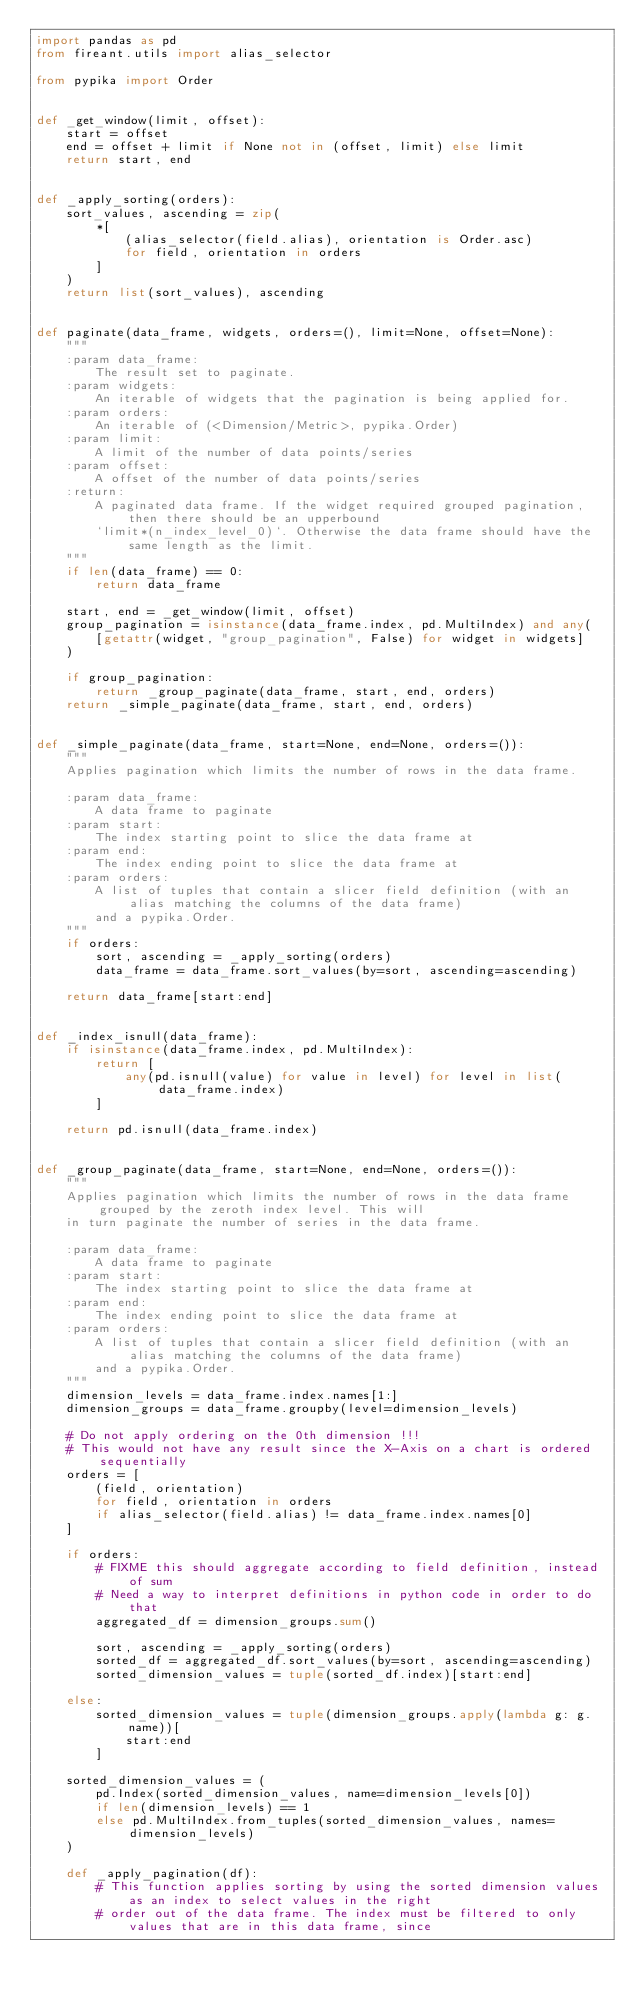Convert code to text. <code><loc_0><loc_0><loc_500><loc_500><_Python_>import pandas as pd
from fireant.utils import alias_selector

from pypika import Order


def _get_window(limit, offset):
    start = offset
    end = offset + limit if None not in (offset, limit) else limit
    return start, end


def _apply_sorting(orders):
    sort_values, ascending = zip(
        *[
            (alias_selector(field.alias), orientation is Order.asc)
            for field, orientation in orders
        ]
    )
    return list(sort_values), ascending


def paginate(data_frame, widgets, orders=(), limit=None, offset=None):
    """
    :param data_frame:
        The result set to paginate.
    :param widgets:
        An iterable of widgets that the pagination is being applied for.
    :param orders:
        An iterable of (<Dimension/Metric>, pypika.Order)
    :param limit:
        A limit of the number of data points/series
    :param offset:
        A offset of the number of data points/series
    :return:
        A paginated data frame. If the widget required grouped pagination, then there should be an upperbound
        `limit*(n_index_level_0)`. Otherwise the data frame should have the same length as the limit.
    """
    if len(data_frame) == 0:
        return data_frame

    start, end = _get_window(limit, offset)
    group_pagination = isinstance(data_frame.index, pd.MultiIndex) and any(
        [getattr(widget, "group_pagination", False) for widget in widgets]
    )

    if group_pagination:
        return _group_paginate(data_frame, start, end, orders)
    return _simple_paginate(data_frame, start, end, orders)


def _simple_paginate(data_frame, start=None, end=None, orders=()):
    """
    Applies pagination which limits the number of rows in the data frame.

    :param data_frame:
        A data frame to paginate
    :param start:
        The index starting point to slice the data frame at
    :param end:
        The index ending point to slice the data frame at
    :param orders:
        A list of tuples that contain a slicer field definition (with an alias matching the columns of the data frame)
        and a pypika.Order.
    """
    if orders:
        sort, ascending = _apply_sorting(orders)
        data_frame = data_frame.sort_values(by=sort, ascending=ascending)

    return data_frame[start:end]


def _index_isnull(data_frame):
    if isinstance(data_frame.index, pd.MultiIndex):
        return [
            any(pd.isnull(value) for value in level) for level in list(data_frame.index)
        ]

    return pd.isnull(data_frame.index)


def _group_paginate(data_frame, start=None, end=None, orders=()):
    """
    Applies pagination which limits the number of rows in the data frame grouped by the zeroth index level. This will
    in turn paginate the number of series in the data frame.

    :param data_frame:
        A data frame to paginate
    :param start:
        The index starting point to slice the data frame at
    :param end:
        The index ending point to slice the data frame at
    :param orders:
        A list of tuples that contain a slicer field definition (with an alias matching the columns of the data frame)
        and a pypika.Order.
    """
    dimension_levels = data_frame.index.names[1:]
    dimension_groups = data_frame.groupby(level=dimension_levels)

    # Do not apply ordering on the 0th dimension !!!
    # This would not have any result since the X-Axis on a chart is ordered sequentially
    orders = [
        (field, orientation)
        for field, orientation in orders
        if alias_selector(field.alias) != data_frame.index.names[0]
    ]

    if orders:
        # FIXME this should aggregate according to field definition, instead of sum
        # Need a way to interpret definitions in python code in order to do that
        aggregated_df = dimension_groups.sum()

        sort, ascending = _apply_sorting(orders)
        sorted_df = aggregated_df.sort_values(by=sort, ascending=ascending)
        sorted_dimension_values = tuple(sorted_df.index)[start:end]

    else:
        sorted_dimension_values = tuple(dimension_groups.apply(lambda g: g.name))[
            start:end
        ]

    sorted_dimension_values = (
        pd.Index(sorted_dimension_values, name=dimension_levels[0])
        if len(dimension_levels) == 1
        else pd.MultiIndex.from_tuples(sorted_dimension_values, names=dimension_levels)
    )

    def _apply_pagination(df):
        # This function applies sorting by using the sorted dimension values as an index to select values in the right
        # order out of the data frame. The index must be filtered to only values that are in this data frame, since</code> 